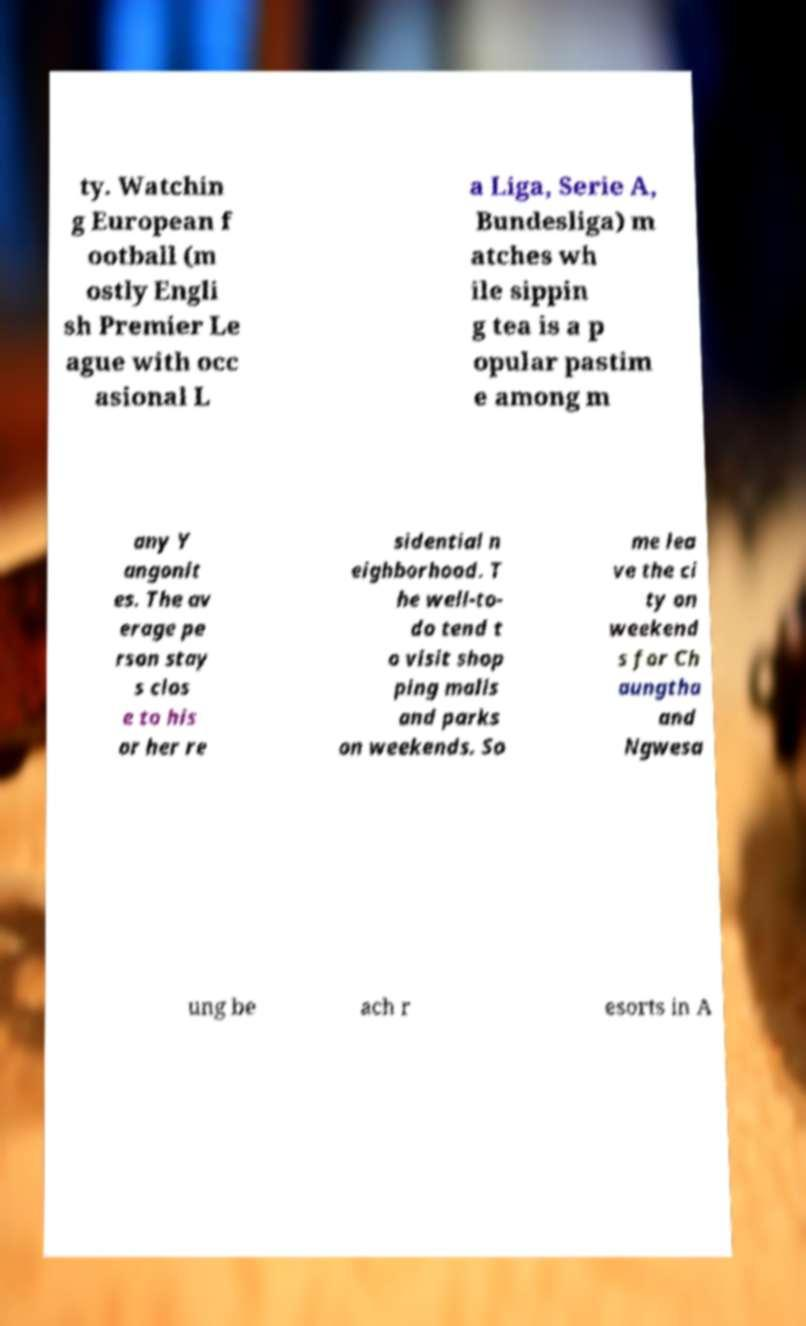I need the written content from this picture converted into text. Can you do that? ty. Watchin g European f ootball (m ostly Engli sh Premier Le ague with occ asional L a Liga, Serie A, Bundesliga) m atches wh ile sippin g tea is a p opular pastim e among m any Y angonit es. The av erage pe rson stay s clos e to his or her re sidential n eighborhood. T he well-to- do tend t o visit shop ping malls and parks on weekends. So me lea ve the ci ty on weekend s for Ch aungtha and Ngwesa ung be ach r esorts in A 